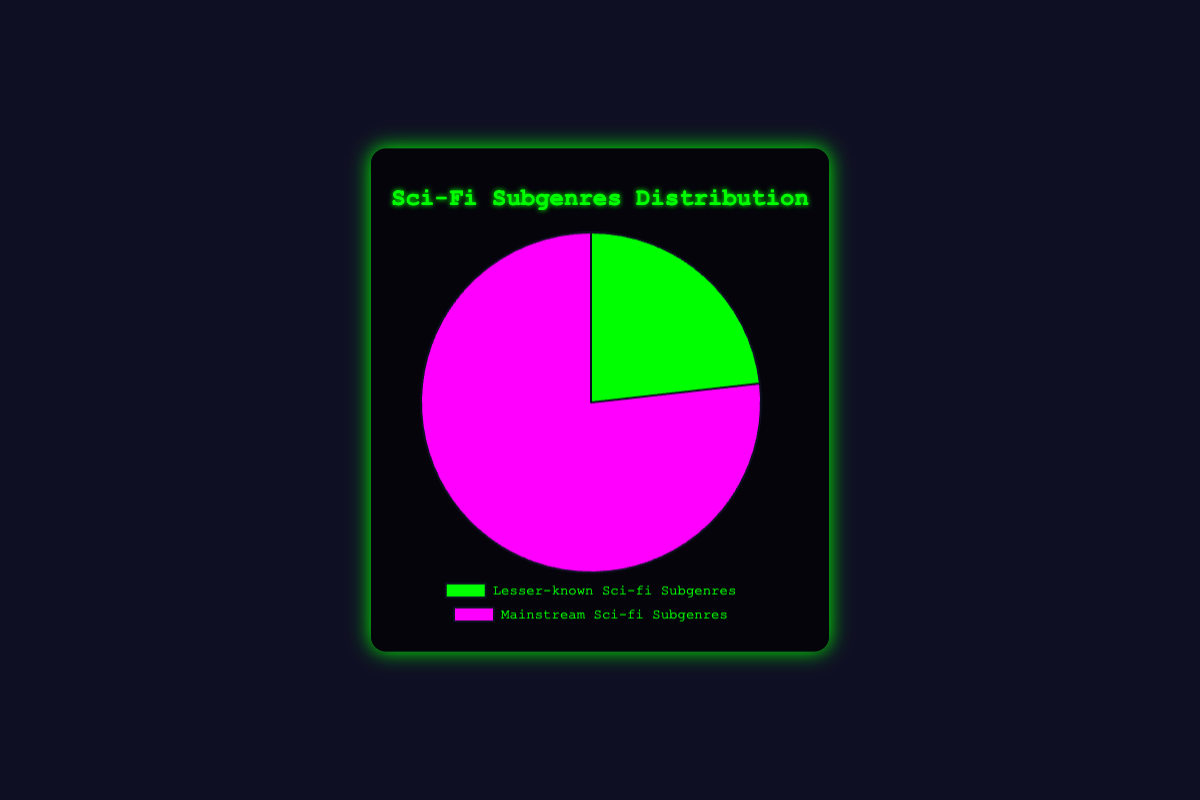What is the percentage distribution of Lesser-known Sci-fi Subgenres in the reviewed books? The Lesser-known Sci-fi Subgenres have a total of 65 reviews out of the combined total of 280 reviews (65 for Lesser-known and 215 for Mainstream). The percentage is calculated by (65 / 280) * 100.
Answer: 23.21% Which Sci-fi subgenre category has more reviews? Comparing the data points, Lesser-known Sci-fi Subgenres have a total of 65 reviews, while Mainstream Sci-fi Subgenres have 215 reviews.
Answer: Mainstream Sci-fi Subgenres What is the difference in the number of reviews between the two sci-fi subgenre categories? Lesser-known Sci-fi Subgenres have 65 reviews, and Mainstream Sci-fi Subgenres have 215 reviews. The difference is 215 - 65.
Answer: 150 If another subgenre with 10 reviews is added to the Lesser-known Sci-fi Subgenres, what will be the new percentage of reviews for this category? Initial reviews for Lesser-known are 65. Adding 10 brings it to 75. The new total reviews are 280 + 10 = 290. The new percentage is (75 / 290) * 100.
Answer: 25.86% How many more reviews does Cyberpunk have compared to Solarpunk from the data provided? Cyberpunk (Mainstream) has 50 reviews, Solarpunk (Lesser-known) has 20 reviews. The difference is 50 - 20.
Answer: 30 Which subgenre has the fewest reviews in the Lesser-known Sci-fi Subgenres category? By comparing the review numbers, Biopunk has 15, Solarpunk has 20, Dieselpunk has 10, Afrofuturism has 12, and Silkpunk has 8 reviews. Silkpunk has the fewest.
Answer: Silkpunk What is the median number of reviews in the Mainstream Sci-fi Subgenres? Mainstream subgenres reviews: Space Opera (45), Cyberpunk (50), Dystopian (55), Post-Apocalyptic (40), Time Travel (25). Arranged in ascending order: 25, 40, 45, 50, 55. The median value is the middle one.
Answer: 45 How does the total number of reviews for Biopunk and Silkpunk combined compare to the reviews for Time Travel? Biopunk has 15, Silkpunk has 8. Combined = 15 + 8 = 23. Time Travel has 25 reviews. Comparison: 23 < 25.
Answer: Less What color represents the Lesser-known Sci-fi Subgenres in the pie chart? According to the data provided, Lesser-known Sci-fi Subgenres are represented by the color green in the pie chart.
Answer: Green Which Mainstream Sci-fi Subgenre has the highest number of reviews, and what is this number? By comparing the review numbers: Space Opera (45), Cyberpunk (50), Dystopian (55), Post-Apocalyptic (40), Time Travel (25). Dystopian has the highest.
Answer: Dystopian, 55 